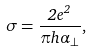Convert formula to latex. <formula><loc_0><loc_0><loc_500><loc_500>\sigma = \frac { 2 e ^ { 2 } } { \pi h \alpha _ { \perp } } ,</formula> 